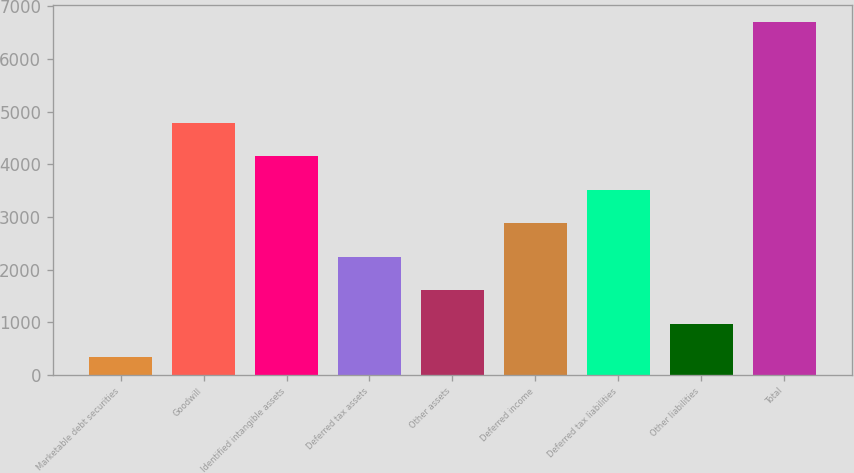Convert chart. <chart><loc_0><loc_0><loc_500><loc_500><bar_chart><fcel>Marketable debt securities<fcel>Goodwill<fcel>Identified intangible assets<fcel>Deferred tax assets<fcel>Other assets<fcel>Deferred income<fcel>Deferred tax liabilities<fcel>Other liabilities<fcel>Total<nl><fcel>329<fcel>4788.7<fcel>4151.6<fcel>2240.3<fcel>1603.2<fcel>2877.4<fcel>3514.5<fcel>966.1<fcel>6700<nl></chart> 